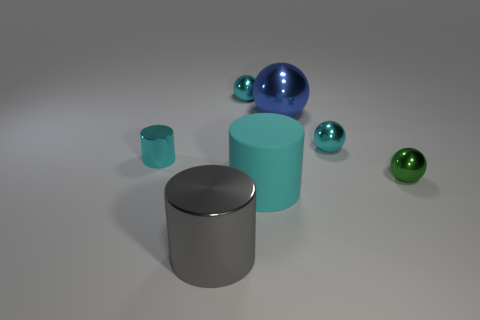Is the color of the metal object on the left side of the large gray metallic thing the same as the metallic cylinder that is in front of the small green metal sphere?
Keep it short and to the point. No. How many big blue metal balls are in front of the cyan matte cylinder?
Make the answer very short. 0. There is a small cylinder that is the same color as the rubber thing; what material is it?
Ensure brevity in your answer.  Metal. Are there any small metal things of the same shape as the large blue thing?
Your response must be concise. Yes. Does the big object that is behind the tiny cyan cylinder have the same material as the small cyan object that is on the left side of the big shiny cylinder?
Offer a terse response. Yes. What size is the metallic thing right of the small cyan metallic object that is on the right side of the tiny cyan object behind the blue metal sphere?
Provide a succinct answer. Small. There is a cyan cylinder that is the same size as the gray metallic object; what is it made of?
Ensure brevity in your answer.  Rubber. Are there any cyan balls that have the same size as the green shiny thing?
Offer a very short reply. Yes. Does the gray shiny object have the same shape as the small green shiny object?
Provide a short and direct response. No. Is there a tiny metal cylinder right of the tiny metal object that is in front of the cyan metal cylinder behind the big cyan cylinder?
Offer a very short reply. No. 